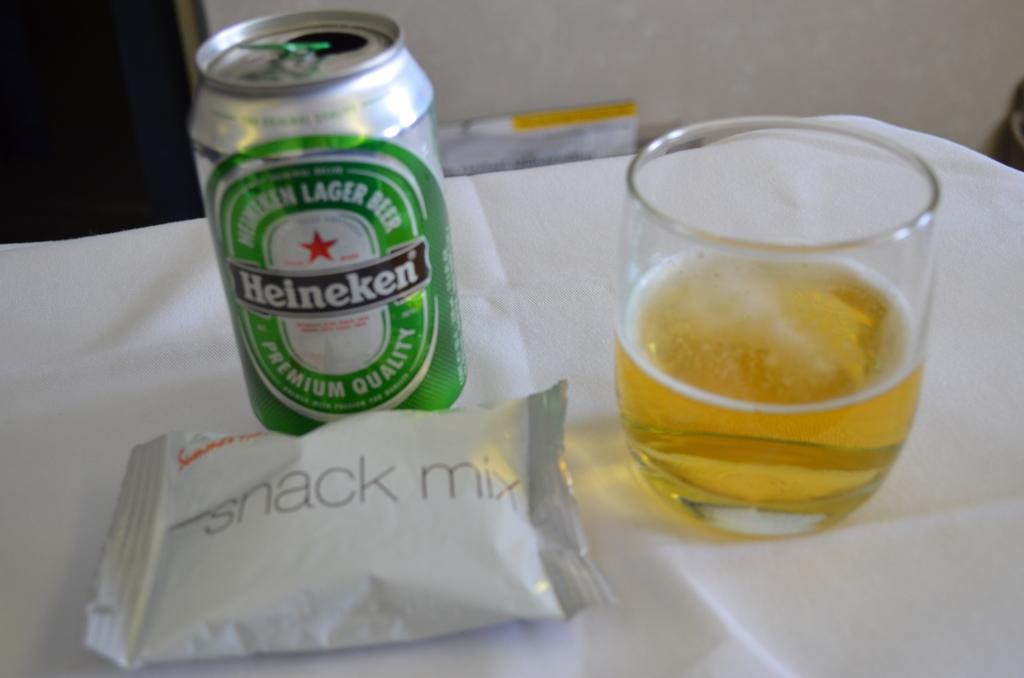Provide a one-sentence caption for the provided image. Can of Heineken beer and Snack mix on a table. 